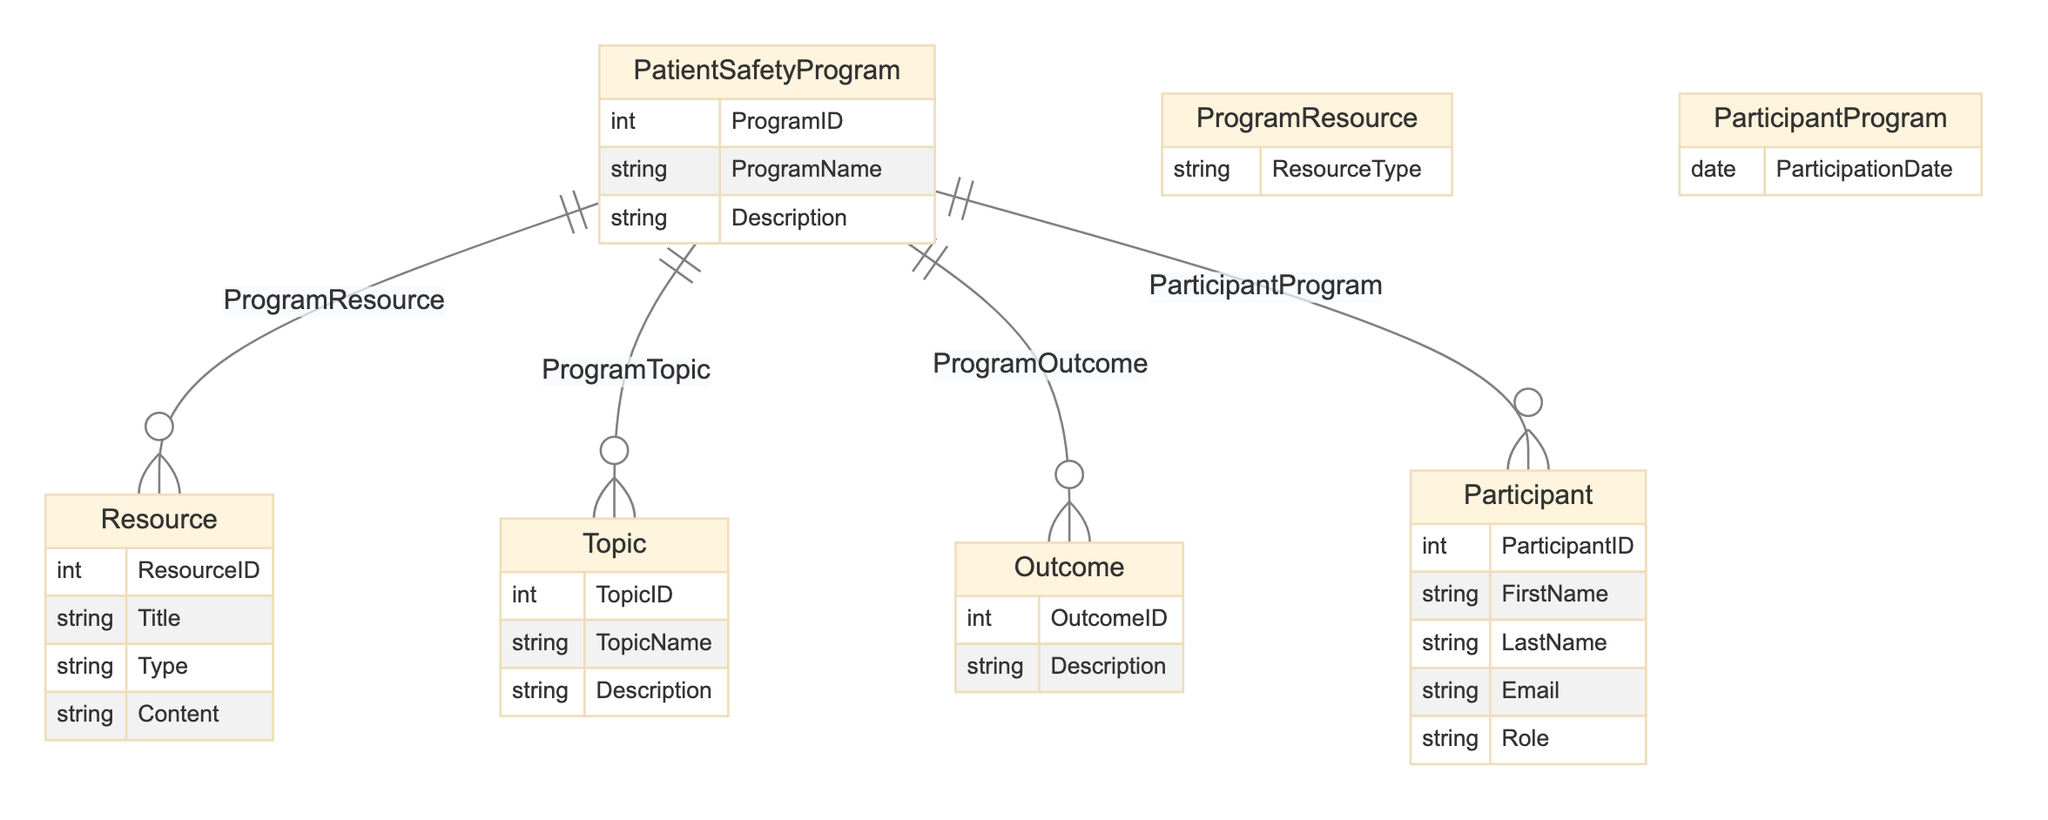what's the primary entity in the diagram? The primary entity is identified as "PatientSafetyProgram," which is the main focus of the diagram. Other entities relate to this primary entity through various relationships.
Answer: PatientSafetyProgram how many entities are there in total? There are five entities represented in the diagram: "PatientSafetyProgram," "Resource," "Topic," "Outcome," and "Participant." Counting them gives a total of five.
Answer: 5 what relationship connects "Participant" to "PatientSafetyProgram"? The relationship connecting "Participant" to "PatientSafetyProgram" is called "ParticipantProgram." This indicates the connection between participants and the program, specifically through their involvement.
Answer: ParticipantProgram what type of information can a "Resource" have? "Resource" can have attributes like "ResourceID," "Title," "Type," and "Content." These attributes describe the characteristics and content of each resource within the program.
Answer: ResourceID, Title, Type, Content which entity describes the expected results of the program? The entity that describes the expected results of the program is "Outcome." This entity represents the outcomes that are anticipated or measured as a result of participating in the patient safety program.
Answer: Outcome how many relationships are there in the diagram? There are four relationships illustrated in the diagram: "ProgramResource," "ProgramTopic," "ProgramOutcome," and "ParticipantProgram." Each relationship links different entities within the structure of the program.
Answer: 4 what is the purpose of the "ProgramResource" relationship? The "ProgramResource" relationship connects "PatientSafetyProgram" with "Resource," indicating which resources are used in the context of the program. This relationship helps understand what materials support the program.
Answer: connect resources to program what attribute is shared between the "Participant" and "PatientSafetyProgram"? The attribute shared in their relationship is "ParticipationDate." This indicates the date on which participants were involved in the program and provides important context for their engagement.
Answer: ParticipationDate which entity contains the attribute "TopicName"? The entity that contains the attribute "TopicName" is "Topic." This gives insight into the specific areas covered within the patient safety education program.
Answer: Topic what is a common attribute of all entities in the diagram? A common attribute among all entities is that they each have unique identifiers: "ProgramID" for PatientSafetyProgram, "ResourceID" for Resource, "TopicID" for Topic, "OutcomeID" for Outcome, and "ParticipantID" for Participant. These identifiers facilitate relationships and data integrity.
Answer: unique identifiers 